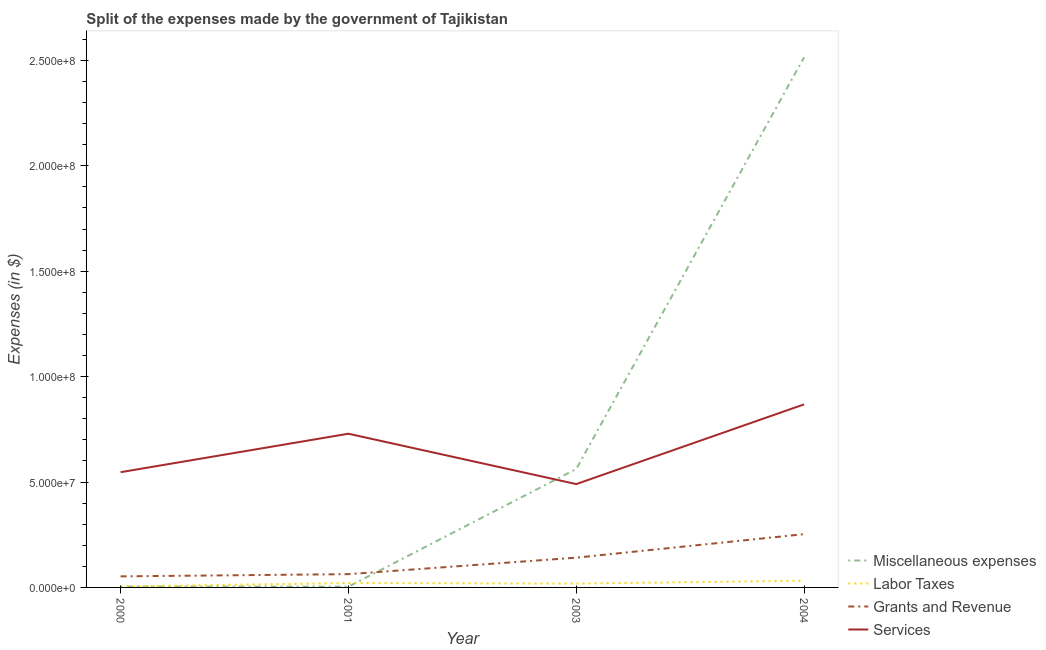How many different coloured lines are there?
Ensure brevity in your answer.  4. Is the number of lines equal to the number of legend labels?
Make the answer very short. Yes. What is the amount spent on services in 2003?
Your answer should be very brief. 4.90e+07. Across all years, what is the maximum amount spent on labor taxes?
Your answer should be very brief. 3.17e+06. Across all years, what is the minimum amount spent on labor taxes?
Ensure brevity in your answer.  4.11e+05. In which year was the amount spent on labor taxes maximum?
Offer a very short reply. 2004. In which year was the amount spent on miscellaneous expenses minimum?
Make the answer very short. 2001. What is the total amount spent on services in the graph?
Make the answer very short. 2.63e+08. What is the difference between the amount spent on labor taxes in 2000 and that in 2003?
Ensure brevity in your answer.  -1.42e+06. What is the difference between the amount spent on labor taxes in 2000 and the amount spent on grants and revenue in 2003?
Keep it short and to the point. -1.37e+07. What is the average amount spent on miscellaneous expenses per year?
Offer a very short reply. 7.71e+07. In the year 2001, what is the difference between the amount spent on grants and revenue and amount spent on services?
Your answer should be very brief. -6.66e+07. What is the ratio of the amount spent on miscellaneous expenses in 2003 to that in 2004?
Offer a very short reply. 0.22. Is the difference between the amount spent on services in 2000 and 2003 greater than the difference between the amount spent on grants and revenue in 2000 and 2003?
Keep it short and to the point. Yes. What is the difference between the highest and the second highest amount spent on miscellaneous expenses?
Your response must be concise. 1.95e+08. What is the difference between the highest and the lowest amount spent on grants and revenue?
Offer a terse response. 2.00e+07. Is the sum of the amount spent on grants and revenue in 2001 and 2003 greater than the maximum amount spent on labor taxes across all years?
Provide a succinct answer. Yes. How many lines are there?
Make the answer very short. 4. How many years are there in the graph?
Provide a short and direct response. 4. Where does the legend appear in the graph?
Offer a terse response. Bottom right. How many legend labels are there?
Your answer should be very brief. 4. How are the legend labels stacked?
Give a very brief answer. Vertical. What is the title of the graph?
Make the answer very short. Split of the expenses made by the government of Tajikistan. What is the label or title of the Y-axis?
Keep it short and to the point. Expenses (in $). What is the Expenses (in $) of Miscellaneous expenses in 2000?
Your answer should be compact. 3.95e+05. What is the Expenses (in $) in Labor Taxes in 2000?
Ensure brevity in your answer.  4.11e+05. What is the Expenses (in $) in Grants and Revenue in 2000?
Make the answer very short. 5.25e+06. What is the Expenses (in $) of Services in 2000?
Offer a very short reply. 5.47e+07. What is the Expenses (in $) in Labor Taxes in 2001?
Make the answer very short. 2.09e+06. What is the Expenses (in $) in Grants and Revenue in 2001?
Offer a terse response. 6.30e+06. What is the Expenses (in $) in Services in 2001?
Provide a succinct answer. 7.29e+07. What is the Expenses (in $) in Miscellaneous expenses in 2003?
Offer a very short reply. 5.62e+07. What is the Expenses (in $) in Labor Taxes in 2003?
Your response must be concise. 1.83e+06. What is the Expenses (in $) in Grants and Revenue in 2003?
Offer a terse response. 1.41e+07. What is the Expenses (in $) of Services in 2003?
Your answer should be very brief. 4.90e+07. What is the Expenses (in $) in Miscellaneous expenses in 2004?
Your answer should be very brief. 2.51e+08. What is the Expenses (in $) of Labor Taxes in 2004?
Offer a very short reply. 3.17e+06. What is the Expenses (in $) in Grants and Revenue in 2004?
Your answer should be compact. 2.53e+07. What is the Expenses (in $) of Services in 2004?
Your answer should be compact. 8.68e+07. Across all years, what is the maximum Expenses (in $) in Miscellaneous expenses?
Your answer should be very brief. 2.51e+08. Across all years, what is the maximum Expenses (in $) of Labor Taxes?
Provide a short and direct response. 3.17e+06. Across all years, what is the maximum Expenses (in $) of Grants and Revenue?
Make the answer very short. 2.53e+07. Across all years, what is the maximum Expenses (in $) of Services?
Your answer should be very brief. 8.68e+07. Across all years, what is the minimum Expenses (in $) in Labor Taxes?
Provide a succinct answer. 4.11e+05. Across all years, what is the minimum Expenses (in $) of Grants and Revenue?
Provide a succinct answer. 5.25e+06. Across all years, what is the minimum Expenses (in $) in Services?
Provide a short and direct response. 4.90e+07. What is the total Expenses (in $) of Miscellaneous expenses in the graph?
Ensure brevity in your answer.  3.08e+08. What is the total Expenses (in $) of Labor Taxes in the graph?
Your response must be concise. 7.50e+06. What is the total Expenses (in $) in Grants and Revenue in the graph?
Your answer should be compact. 5.10e+07. What is the total Expenses (in $) in Services in the graph?
Give a very brief answer. 2.63e+08. What is the difference between the Expenses (in $) of Miscellaneous expenses in 2000 and that in 2001?
Ensure brevity in your answer.  2.50e+04. What is the difference between the Expenses (in $) in Labor Taxes in 2000 and that in 2001?
Your answer should be compact. -1.68e+06. What is the difference between the Expenses (in $) in Grants and Revenue in 2000 and that in 2001?
Keep it short and to the point. -1.05e+06. What is the difference between the Expenses (in $) in Services in 2000 and that in 2001?
Your answer should be compact. -1.82e+07. What is the difference between the Expenses (in $) of Miscellaneous expenses in 2000 and that in 2003?
Provide a short and direct response. -5.58e+07. What is the difference between the Expenses (in $) in Labor Taxes in 2000 and that in 2003?
Keep it short and to the point. -1.42e+06. What is the difference between the Expenses (in $) of Grants and Revenue in 2000 and that in 2003?
Provide a short and direct response. -8.87e+06. What is the difference between the Expenses (in $) in Services in 2000 and that in 2003?
Provide a short and direct response. 5.65e+06. What is the difference between the Expenses (in $) in Miscellaneous expenses in 2000 and that in 2004?
Provide a succinct answer. -2.51e+08. What is the difference between the Expenses (in $) in Labor Taxes in 2000 and that in 2004?
Give a very brief answer. -2.76e+06. What is the difference between the Expenses (in $) of Grants and Revenue in 2000 and that in 2004?
Your response must be concise. -2.00e+07. What is the difference between the Expenses (in $) in Services in 2000 and that in 2004?
Give a very brief answer. -3.22e+07. What is the difference between the Expenses (in $) of Miscellaneous expenses in 2001 and that in 2003?
Make the answer very short. -5.58e+07. What is the difference between the Expenses (in $) in Labor Taxes in 2001 and that in 2003?
Keep it short and to the point. 2.58e+05. What is the difference between the Expenses (in $) in Grants and Revenue in 2001 and that in 2003?
Provide a succinct answer. -7.82e+06. What is the difference between the Expenses (in $) in Services in 2001 and that in 2003?
Ensure brevity in your answer.  2.39e+07. What is the difference between the Expenses (in $) of Miscellaneous expenses in 2001 and that in 2004?
Provide a short and direct response. -2.51e+08. What is the difference between the Expenses (in $) of Labor Taxes in 2001 and that in 2004?
Keep it short and to the point. -1.08e+06. What is the difference between the Expenses (in $) of Grants and Revenue in 2001 and that in 2004?
Provide a short and direct response. -1.90e+07. What is the difference between the Expenses (in $) in Services in 2001 and that in 2004?
Offer a very short reply. -1.39e+07. What is the difference between the Expenses (in $) in Miscellaneous expenses in 2003 and that in 2004?
Offer a terse response. -1.95e+08. What is the difference between the Expenses (in $) of Labor Taxes in 2003 and that in 2004?
Your answer should be compact. -1.34e+06. What is the difference between the Expenses (in $) in Grants and Revenue in 2003 and that in 2004?
Offer a very short reply. -1.12e+07. What is the difference between the Expenses (in $) of Services in 2003 and that in 2004?
Give a very brief answer. -3.78e+07. What is the difference between the Expenses (in $) in Miscellaneous expenses in 2000 and the Expenses (in $) in Labor Taxes in 2001?
Give a very brief answer. -1.69e+06. What is the difference between the Expenses (in $) in Miscellaneous expenses in 2000 and the Expenses (in $) in Grants and Revenue in 2001?
Keep it short and to the point. -5.90e+06. What is the difference between the Expenses (in $) of Miscellaneous expenses in 2000 and the Expenses (in $) of Services in 2001?
Your response must be concise. -7.25e+07. What is the difference between the Expenses (in $) of Labor Taxes in 2000 and the Expenses (in $) of Grants and Revenue in 2001?
Ensure brevity in your answer.  -5.89e+06. What is the difference between the Expenses (in $) in Labor Taxes in 2000 and the Expenses (in $) in Services in 2001?
Your answer should be very brief. -7.25e+07. What is the difference between the Expenses (in $) of Grants and Revenue in 2000 and the Expenses (in $) of Services in 2001?
Offer a terse response. -6.77e+07. What is the difference between the Expenses (in $) of Miscellaneous expenses in 2000 and the Expenses (in $) of Labor Taxes in 2003?
Provide a succinct answer. -1.43e+06. What is the difference between the Expenses (in $) in Miscellaneous expenses in 2000 and the Expenses (in $) in Grants and Revenue in 2003?
Offer a very short reply. -1.37e+07. What is the difference between the Expenses (in $) in Miscellaneous expenses in 2000 and the Expenses (in $) in Services in 2003?
Keep it short and to the point. -4.86e+07. What is the difference between the Expenses (in $) in Labor Taxes in 2000 and the Expenses (in $) in Grants and Revenue in 2003?
Provide a succinct answer. -1.37e+07. What is the difference between the Expenses (in $) in Labor Taxes in 2000 and the Expenses (in $) in Services in 2003?
Ensure brevity in your answer.  -4.86e+07. What is the difference between the Expenses (in $) in Grants and Revenue in 2000 and the Expenses (in $) in Services in 2003?
Offer a very short reply. -4.38e+07. What is the difference between the Expenses (in $) in Miscellaneous expenses in 2000 and the Expenses (in $) in Labor Taxes in 2004?
Your answer should be compact. -2.78e+06. What is the difference between the Expenses (in $) in Miscellaneous expenses in 2000 and the Expenses (in $) in Grants and Revenue in 2004?
Your answer should be compact. -2.49e+07. What is the difference between the Expenses (in $) in Miscellaneous expenses in 2000 and the Expenses (in $) in Services in 2004?
Offer a terse response. -8.64e+07. What is the difference between the Expenses (in $) in Labor Taxes in 2000 and the Expenses (in $) in Grants and Revenue in 2004?
Your response must be concise. -2.49e+07. What is the difference between the Expenses (in $) in Labor Taxes in 2000 and the Expenses (in $) in Services in 2004?
Your answer should be very brief. -8.64e+07. What is the difference between the Expenses (in $) in Grants and Revenue in 2000 and the Expenses (in $) in Services in 2004?
Make the answer very short. -8.16e+07. What is the difference between the Expenses (in $) in Miscellaneous expenses in 2001 and the Expenses (in $) in Labor Taxes in 2003?
Your answer should be very brief. -1.46e+06. What is the difference between the Expenses (in $) of Miscellaneous expenses in 2001 and the Expenses (in $) of Grants and Revenue in 2003?
Your answer should be compact. -1.38e+07. What is the difference between the Expenses (in $) in Miscellaneous expenses in 2001 and the Expenses (in $) in Services in 2003?
Make the answer very short. -4.86e+07. What is the difference between the Expenses (in $) in Labor Taxes in 2001 and the Expenses (in $) in Grants and Revenue in 2003?
Provide a succinct answer. -1.20e+07. What is the difference between the Expenses (in $) of Labor Taxes in 2001 and the Expenses (in $) of Services in 2003?
Offer a very short reply. -4.69e+07. What is the difference between the Expenses (in $) of Grants and Revenue in 2001 and the Expenses (in $) of Services in 2003?
Your response must be concise. -4.27e+07. What is the difference between the Expenses (in $) in Miscellaneous expenses in 2001 and the Expenses (in $) in Labor Taxes in 2004?
Give a very brief answer. -2.80e+06. What is the difference between the Expenses (in $) in Miscellaneous expenses in 2001 and the Expenses (in $) in Grants and Revenue in 2004?
Provide a short and direct response. -2.49e+07. What is the difference between the Expenses (in $) in Miscellaneous expenses in 2001 and the Expenses (in $) in Services in 2004?
Give a very brief answer. -8.65e+07. What is the difference between the Expenses (in $) in Labor Taxes in 2001 and the Expenses (in $) in Grants and Revenue in 2004?
Make the answer very short. -2.32e+07. What is the difference between the Expenses (in $) in Labor Taxes in 2001 and the Expenses (in $) in Services in 2004?
Provide a succinct answer. -8.48e+07. What is the difference between the Expenses (in $) of Grants and Revenue in 2001 and the Expenses (in $) of Services in 2004?
Your answer should be compact. -8.05e+07. What is the difference between the Expenses (in $) of Miscellaneous expenses in 2003 and the Expenses (in $) of Labor Taxes in 2004?
Make the answer very short. 5.30e+07. What is the difference between the Expenses (in $) in Miscellaneous expenses in 2003 and the Expenses (in $) in Grants and Revenue in 2004?
Offer a terse response. 3.09e+07. What is the difference between the Expenses (in $) in Miscellaneous expenses in 2003 and the Expenses (in $) in Services in 2004?
Give a very brief answer. -3.07e+07. What is the difference between the Expenses (in $) in Labor Taxes in 2003 and the Expenses (in $) in Grants and Revenue in 2004?
Make the answer very short. -2.34e+07. What is the difference between the Expenses (in $) in Labor Taxes in 2003 and the Expenses (in $) in Services in 2004?
Your answer should be compact. -8.50e+07. What is the difference between the Expenses (in $) in Grants and Revenue in 2003 and the Expenses (in $) in Services in 2004?
Give a very brief answer. -7.27e+07. What is the average Expenses (in $) in Miscellaneous expenses per year?
Offer a very short reply. 7.71e+07. What is the average Expenses (in $) of Labor Taxes per year?
Your answer should be compact. 1.87e+06. What is the average Expenses (in $) in Grants and Revenue per year?
Your answer should be very brief. 1.27e+07. What is the average Expenses (in $) of Services per year?
Your answer should be very brief. 6.59e+07. In the year 2000, what is the difference between the Expenses (in $) in Miscellaneous expenses and Expenses (in $) in Labor Taxes?
Offer a very short reply. -1.60e+04. In the year 2000, what is the difference between the Expenses (in $) of Miscellaneous expenses and Expenses (in $) of Grants and Revenue?
Give a very brief answer. -4.86e+06. In the year 2000, what is the difference between the Expenses (in $) of Miscellaneous expenses and Expenses (in $) of Services?
Give a very brief answer. -5.43e+07. In the year 2000, what is the difference between the Expenses (in $) in Labor Taxes and Expenses (in $) in Grants and Revenue?
Give a very brief answer. -4.84e+06. In the year 2000, what is the difference between the Expenses (in $) of Labor Taxes and Expenses (in $) of Services?
Provide a succinct answer. -5.43e+07. In the year 2000, what is the difference between the Expenses (in $) in Grants and Revenue and Expenses (in $) in Services?
Offer a terse response. -4.94e+07. In the year 2001, what is the difference between the Expenses (in $) of Miscellaneous expenses and Expenses (in $) of Labor Taxes?
Give a very brief answer. -1.72e+06. In the year 2001, what is the difference between the Expenses (in $) in Miscellaneous expenses and Expenses (in $) in Grants and Revenue?
Your response must be concise. -5.93e+06. In the year 2001, what is the difference between the Expenses (in $) in Miscellaneous expenses and Expenses (in $) in Services?
Offer a terse response. -7.25e+07. In the year 2001, what is the difference between the Expenses (in $) in Labor Taxes and Expenses (in $) in Grants and Revenue?
Your response must be concise. -4.21e+06. In the year 2001, what is the difference between the Expenses (in $) of Labor Taxes and Expenses (in $) of Services?
Ensure brevity in your answer.  -7.08e+07. In the year 2001, what is the difference between the Expenses (in $) of Grants and Revenue and Expenses (in $) of Services?
Make the answer very short. -6.66e+07. In the year 2003, what is the difference between the Expenses (in $) in Miscellaneous expenses and Expenses (in $) in Labor Taxes?
Offer a terse response. 5.44e+07. In the year 2003, what is the difference between the Expenses (in $) in Miscellaneous expenses and Expenses (in $) in Grants and Revenue?
Keep it short and to the point. 4.21e+07. In the year 2003, what is the difference between the Expenses (in $) in Miscellaneous expenses and Expenses (in $) in Services?
Make the answer very short. 7.16e+06. In the year 2003, what is the difference between the Expenses (in $) in Labor Taxes and Expenses (in $) in Grants and Revenue?
Provide a short and direct response. -1.23e+07. In the year 2003, what is the difference between the Expenses (in $) in Labor Taxes and Expenses (in $) in Services?
Offer a terse response. -4.72e+07. In the year 2003, what is the difference between the Expenses (in $) in Grants and Revenue and Expenses (in $) in Services?
Offer a very short reply. -3.49e+07. In the year 2004, what is the difference between the Expenses (in $) of Miscellaneous expenses and Expenses (in $) of Labor Taxes?
Keep it short and to the point. 2.48e+08. In the year 2004, what is the difference between the Expenses (in $) in Miscellaneous expenses and Expenses (in $) in Grants and Revenue?
Your response must be concise. 2.26e+08. In the year 2004, what is the difference between the Expenses (in $) in Miscellaneous expenses and Expenses (in $) in Services?
Offer a terse response. 1.65e+08. In the year 2004, what is the difference between the Expenses (in $) in Labor Taxes and Expenses (in $) in Grants and Revenue?
Ensure brevity in your answer.  -2.21e+07. In the year 2004, what is the difference between the Expenses (in $) of Labor Taxes and Expenses (in $) of Services?
Make the answer very short. -8.37e+07. In the year 2004, what is the difference between the Expenses (in $) in Grants and Revenue and Expenses (in $) in Services?
Your response must be concise. -6.16e+07. What is the ratio of the Expenses (in $) of Miscellaneous expenses in 2000 to that in 2001?
Your answer should be compact. 1.07. What is the ratio of the Expenses (in $) in Labor Taxes in 2000 to that in 2001?
Offer a terse response. 0.2. What is the ratio of the Expenses (in $) of Grants and Revenue in 2000 to that in 2001?
Provide a succinct answer. 0.83. What is the ratio of the Expenses (in $) in Services in 2000 to that in 2001?
Offer a very short reply. 0.75. What is the ratio of the Expenses (in $) of Miscellaneous expenses in 2000 to that in 2003?
Keep it short and to the point. 0.01. What is the ratio of the Expenses (in $) of Labor Taxes in 2000 to that in 2003?
Your response must be concise. 0.22. What is the ratio of the Expenses (in $) of Grants and Revenue in 2000 to that in 2003?
Keep it short and to the point. 0.37. What is the ratio of the Expenses (in $) in Services in 2000 to that in 2003?
Offer a terse response. 1.12. What is the ratio of the Expenses (in $) of Miscellaneous expenses in 2000 to that in 2004?
Your response must be concise. 0. What is the ratio of the Expenses (in $) in Labor Taxes in 2000 to that in 2004?
Give a very brief answer. 0.13. What is the ratio of the Expenses (in $) of Grants and Revenue in 2000 to that in 2004?
Give a very brief answer. 0.21. What is the ratio of the Expenses (in $) of Services in 2000 to that in 2004?
Keep it short and to the point. 0.63. What is the ratio of the Expenses (in $) in Miscellaneous expenses in 2001 to that in 2003?
Your response must be concise. 0.01. What is the ratio of the Expenses (in $) of Labor Taxes in 2001 to that in 2003?
Your answer should be compact. 1.14. What is the ratio of the Expenses (in $) in Grants and Revenue in 2001 to that in 2003?
Your answer should be compact. 0.45. What is the ratio of the Expenses (in $) of Services in 2001 to that in 2003?
Give a very brief answer. 1.49. What is the ratio of the Expenses (in $) of Miscellaneous expenses in 2001 to that in 2004?
Your answer should be very brief. 0. What is the ratio of the Expenses (in $) of Labor Taxes in 2001 to that in 2004?
Give a very brief answer. 0.66. What is the ratio of the Expenses (in $) in Grants and Revenue in 2001 to that in 2004?
Make the answer very short. 0.25. What is the ratio of the Expenses (in $) in Services in 2001 to that in 2004?
Offer a terse response. 0.84. What is the ratio of the Expenses (in $) in Miscellaneous expenses in 2003 to that in 2004?
Your response must be concise. 0.22. What is the ratio of the Expenses (in $) of Labor Taxes in 2003 to that in 2004?
Provide a succinct answer. 0.58. What is the ratio of the Expenses (in $) in Grants and Revenue in 2003 to that in 2004?
Your answer should be very brief. 0.56. What is the ratio of the Expenses (in $) of Services in 2003 to that in 2004?
Offer a very short reply. 0.56. What is the difference between the highest and the second highest Expenses (in $) in Miscellaneous expenses?
Ensure brevity in your answer.  1.95e+08. What is the difference between the highest and the second highest Expenses (in $) of Labor Taxes?
Give a very brief answer. 1.08e+06. What is the difference between the highest and the second highest Expenses (in $) in Grants and Revenue?
Your response must be concise. 1.12e+07. What is the difference between the highest and the second highest Expenses (in $) of Services?
Your response must be concise. 1.39e+07. What is the difference between the highest and the lowest Expenses (in $) of Miscellaneous expenses?
Offer a terse response. 2.51e+08. What is the difference between the highest and the lowest Expenses (in $) of Labor Taxes?
Ensure brevity in your answer.  2.76e+06. What is the difference between the highest and the lowest Expenses (in $) in Grants and Revenue?
Ensure brevity in your answer.  2.00e+07. What is the difference between the highest and the lowest Expenses (in $) in Services?
Give a very brief answer. 3.78e+07. 